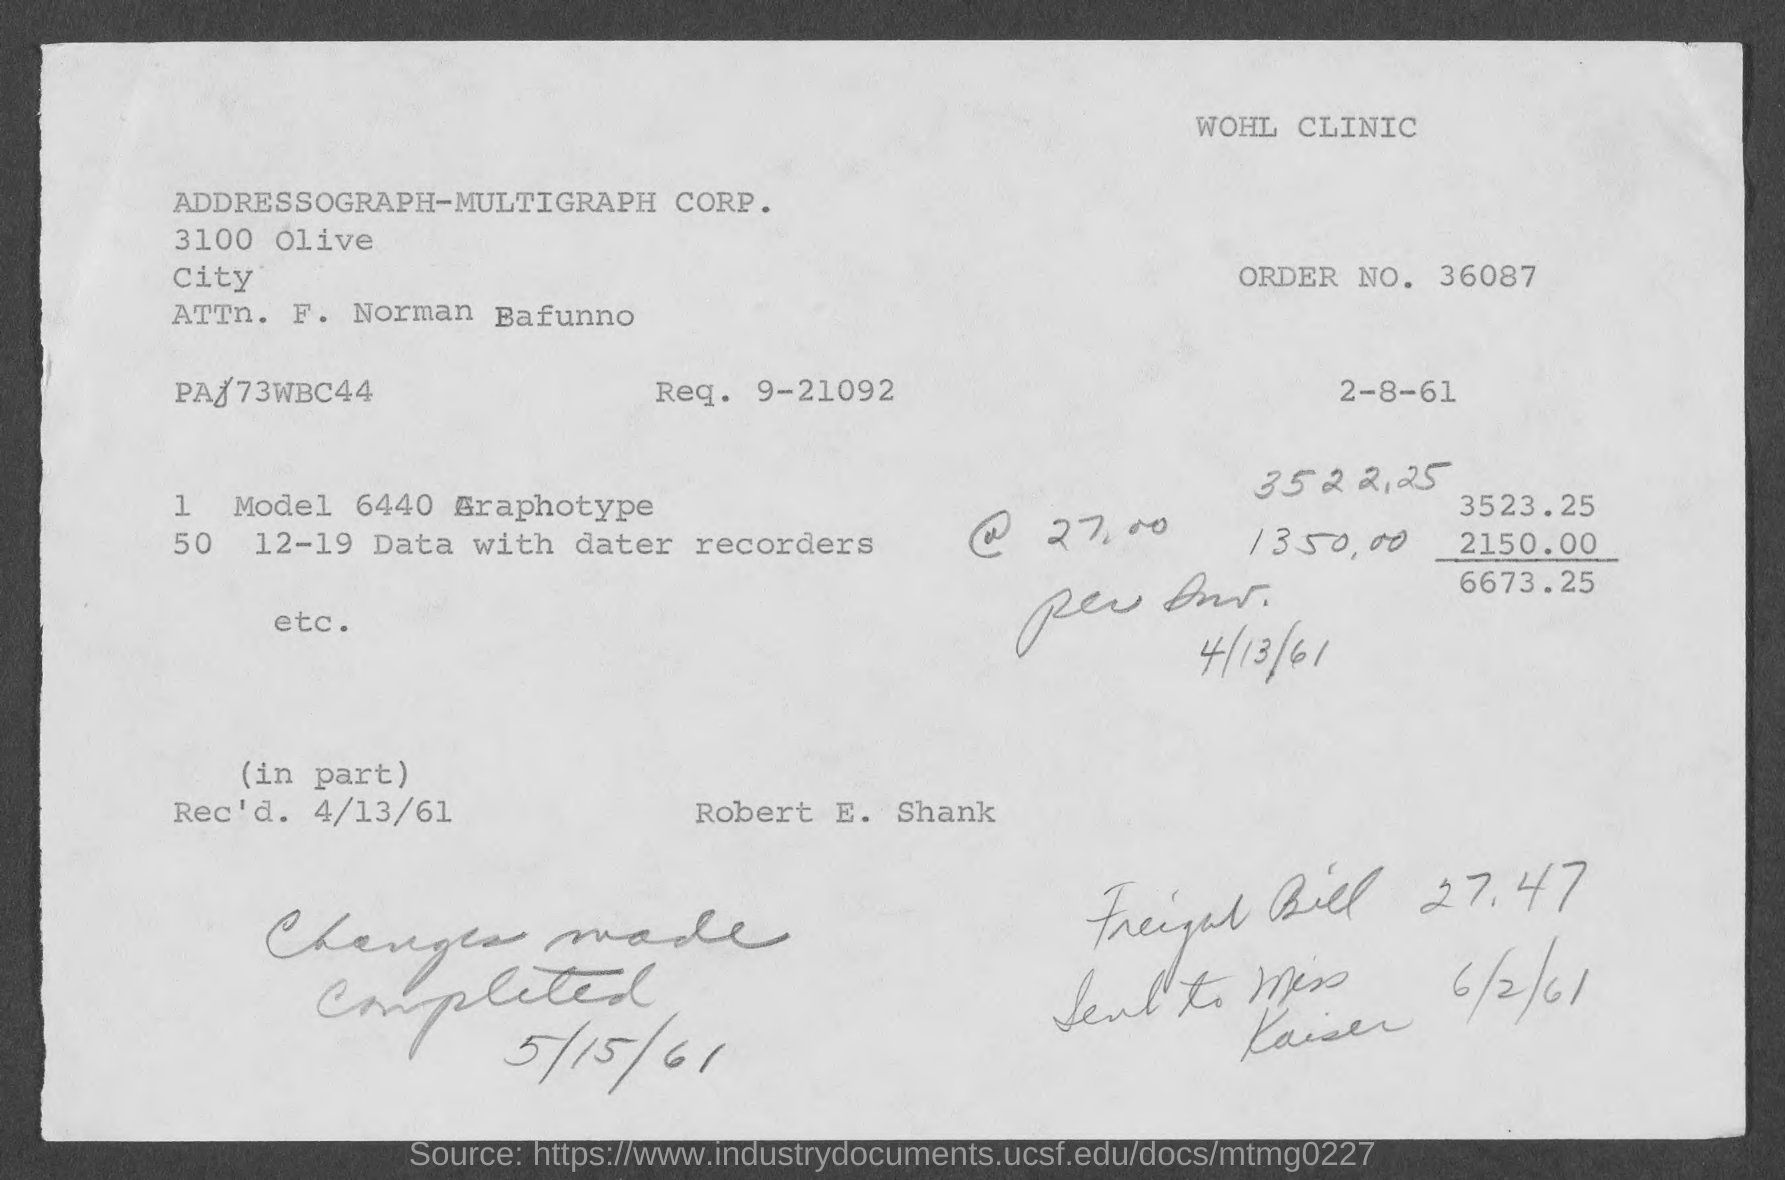Identify some key points in this picture. I request number 9-21092. The person's name is F. Norman Bafunno. The order number is 36087... 